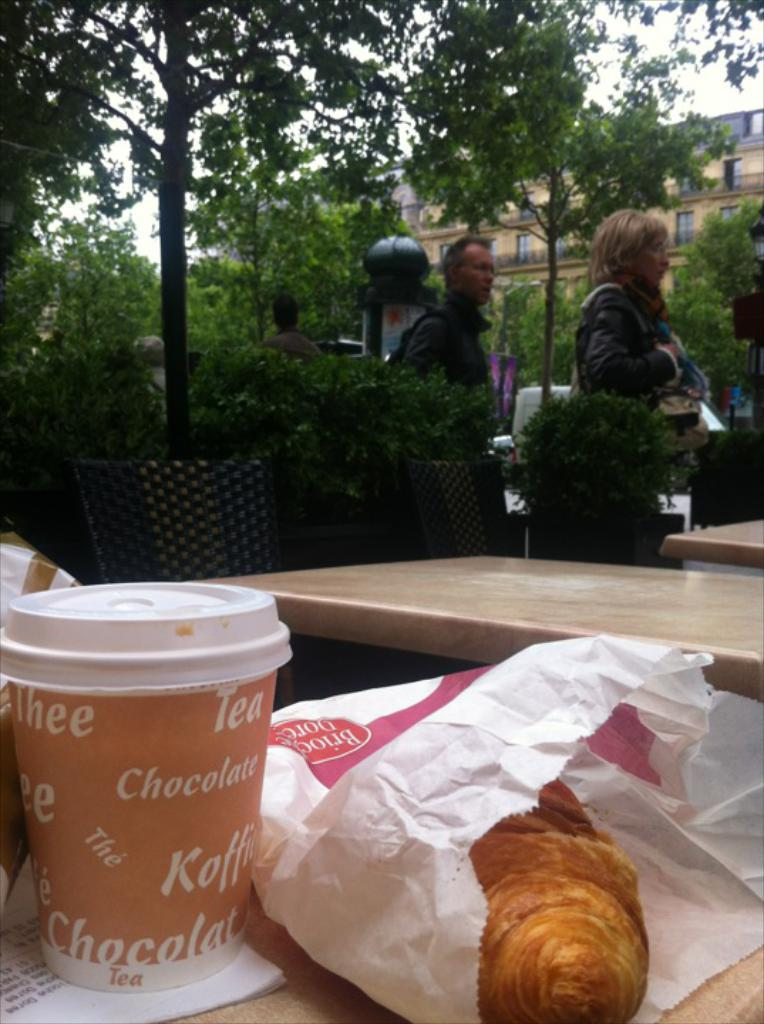Who or what can be seen in the image? There are people in the image. What natural element is present in the image? There is a tree in the image. What man-made structure is visible in the image? There is a building in the image. What architectural features can be seen in the image? There are windows in the image. What type of furniture is present in the image? There are chairs and tables in the image. What items are on the table in the image? There is food and cups on the table. Can you tell me how many trains are visible in the image? There are no trains present in the image. What color is the pocket in the image? There is no pocket present in the image. 